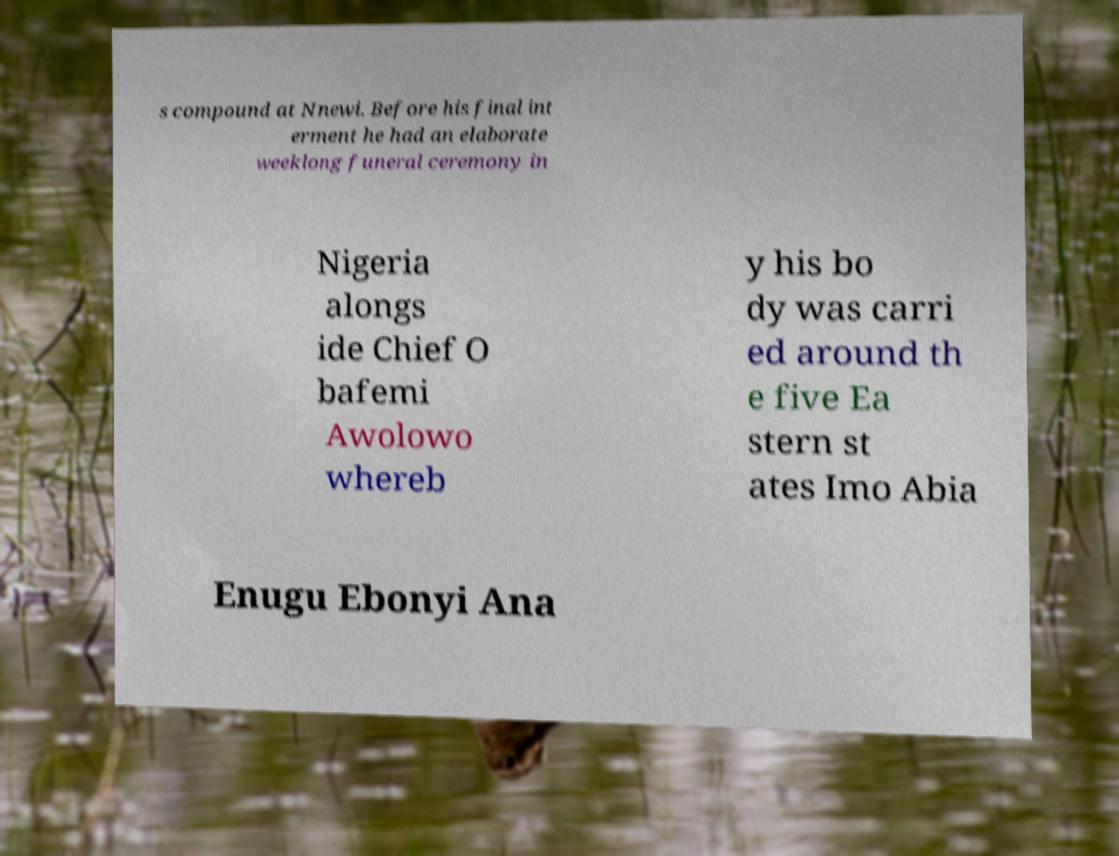What messages or text are displayed in this image? I need them in a readable, typed format. s compound at Nnewi. Before his final int erment he had an elaborate weeklong funeral ceremony in Nigeria alongs ide Chief O bafemi Awolowo whereb y his bo dy was carri ed around th e five Ea stern st ates Imo Abia Enugu Ebonyi Ana 